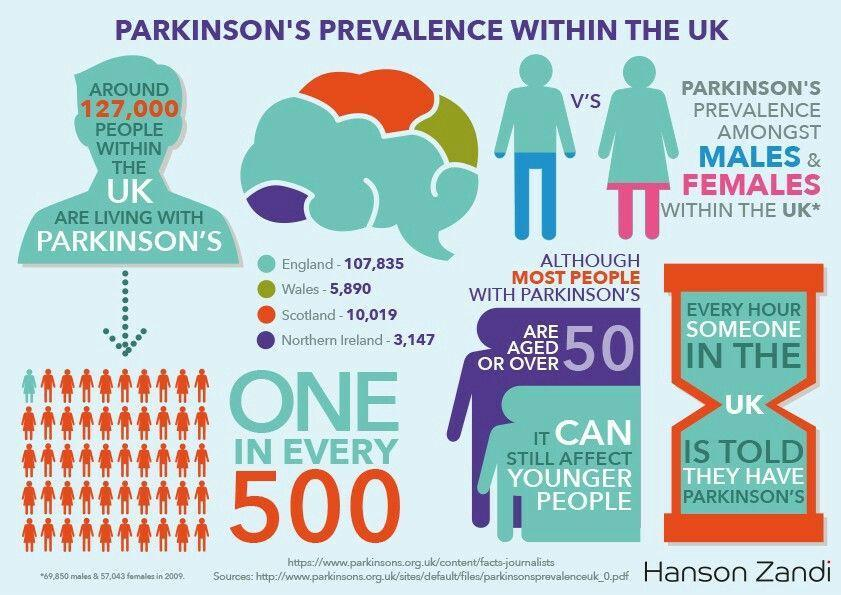Which country in UK has the second highest number of Parkinson's affected people?
Answer the question with a short phrase. Scotland Among which gender Parkinson's disease is found more? Males What is the color used to map the Parkinson's affected people in Scotland- yellow, orange, blue, red? orange What is the severity of Parkinson's disease among UK people? ONE in every 500 How many countries are listed in the info graphic with their prevalence in Parkinson's disease? 4 Which country in UK has the third highest number of Parkinson's affected people? Wales 